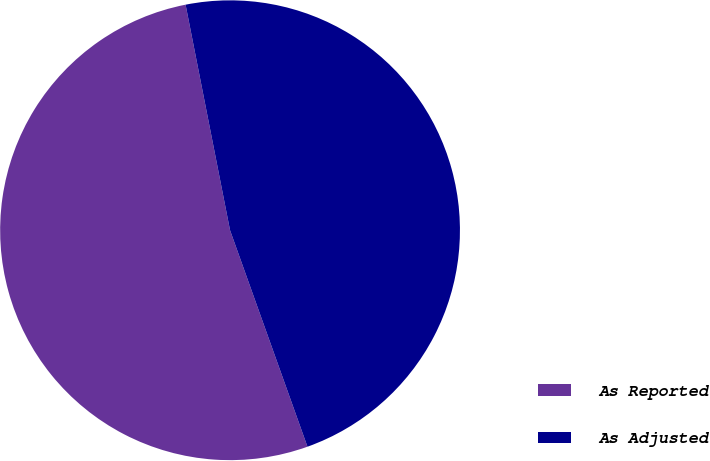Convert chart. <chart><loc_0><loc_0><loc_500><loc_500><pie_chart><fcel>As Reported<fcel>As Adjusted<nl><fcel>52.37%<fcel>47.63%<nl></chart> 